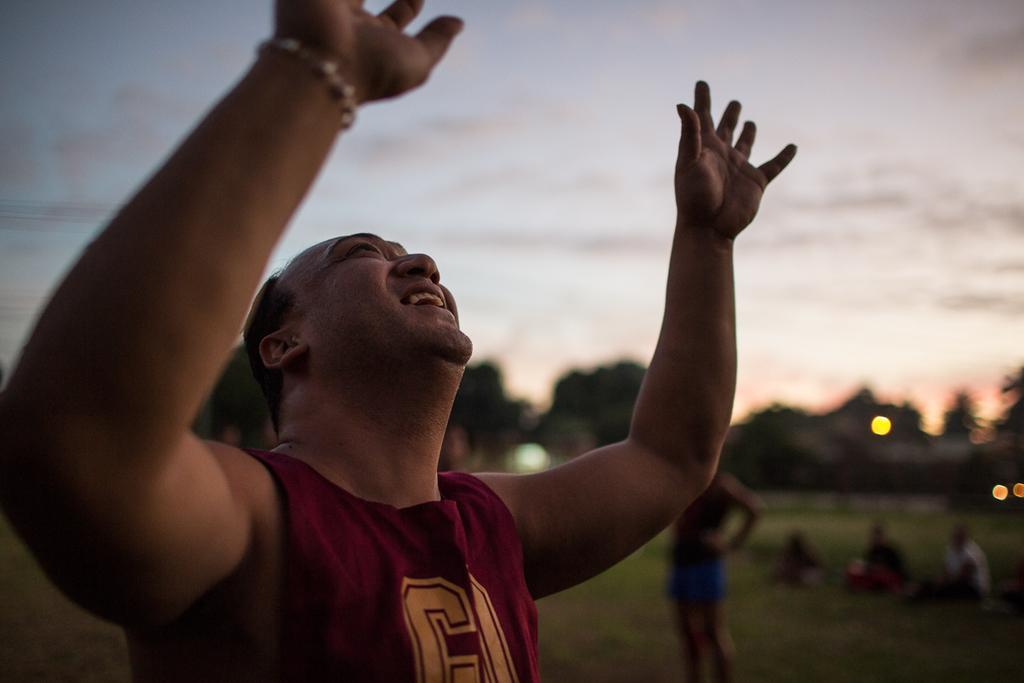What are the persons in the image doing? The persons in the image are sitting and standing on the ground. What can be seen in the background of the image? There is sky and trees visible in the background of the image. What is the condition of the sky in the image? The sky has clouds in the image. How many cows are grazing on the ground in the image? There are no cows present in the image; it features persons sitting and standing on the ground. What type of ground is visible in the image? The ground in the image is not specified, but it is the surface on which the persons are sitting and standing. 